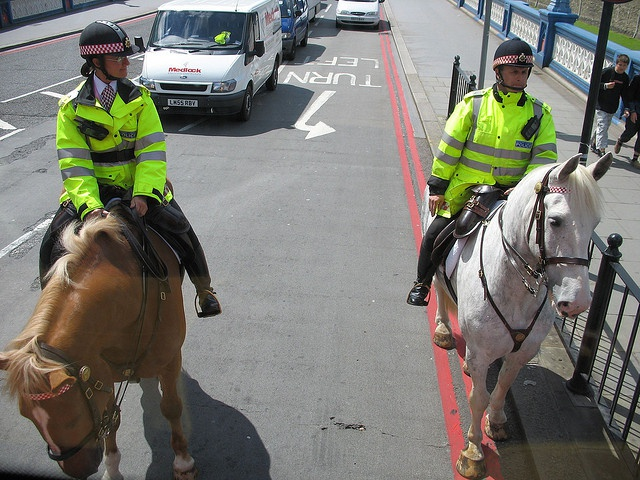Describe the objects in this image and their specific colors. I can see horse in black, maroon, and gray tones, horse in black, gray, lightgray, and darkgray tones, people in black, gray, olive, and lime tones, people in black, gray, olive, and lime tones, and car in black, white, darkgray, and gray tones in this image. 